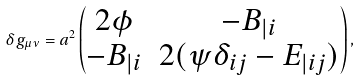Convert formula to latex. <formula><loc_0><loc_0><loc_500><loc_500>\delta g _ { \mu \nu } = a ^ { 2 } \begin{pmatrix} 2 \phi & - B _ { | i } \\ - B _ { | i } & 2 ( \psi \delta _ { i j } - E _ { | i j } ) \end{pmatrix} ,</formula> 